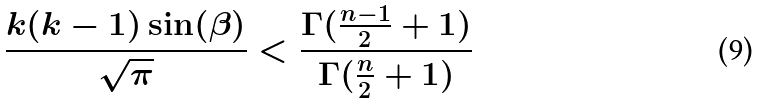Convert formula to latex. <formula><loc_0><loc_0><loc_500><loc_500>\frac { k ( k - 1 ) \sin ( \beta ) } { \sqrt { \pi } } < \frac { \Gamma ( \frac { n - 1 } { 2 } + 1 ) } { \Gamma ( \frac { n } { 2 } + 1 ) }</formula> 